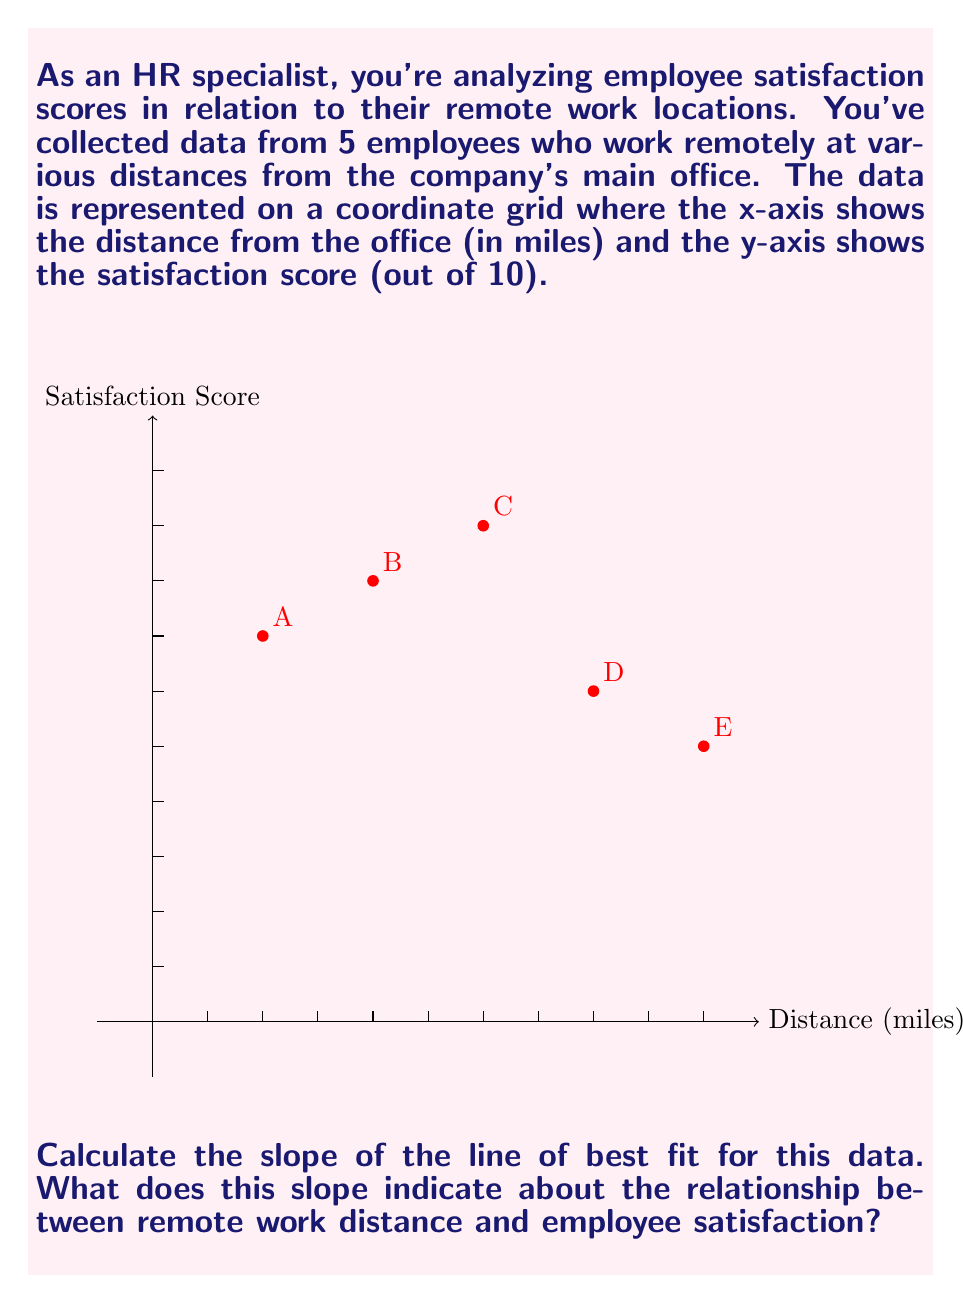Solve this math problem. To solve this problem, we'll follow these steps:

1) First, we need to calculate the line of best fit using the least squares method. The formula for the slope (m) of the line of best fit is:

   $$m = \frac{n\sum{xy} - \sum{x}\sum{y}}{n\sum{x^2} - (\sum{x})^2}$$

   where n is the number of data points, x is the distance, and y is the satisfaction score.

2) Let's calculate the necessary sums:
   n = 5
   $\sum{x} = 2 + 4 + 6 + 8 + 10 = 30$
   $\sum{y} = 7 + 8 + 9 + 6 + 5 = 35$
   $\sum{xy} = (2)(7) + (4)(8) + (6)(9) + (8)(6) + (10)(5) = 214$
   $\sum{x^2} = 2^2 + 4^2 + 6^2 + 8^2 + 10^2 = 220$

3) Now, let's plug these values into the slope formula:

   $$m = \frac{5(214) - (30)(35)}{5(220) - (30)^2}$$

4) Simplify:
   $$m = \frac{1070 - 1050}{1100 - 900} = \frac{20}{200} = -0.1$$

5) Interpret the result:
   The slope is -0.1, which means that for every 1 mile increase in distance from the office, the employee satisfaction score decreases by 0.1 points on average.

This negative slope indicates an inverse relationship between remote work distance and employee satisfaction. As employees work from locations farther from the office, their satisfaction tends to decrease slightly.
Answer: $m = -0.1$; indicates inverse relationship between distance and satisfaction. 